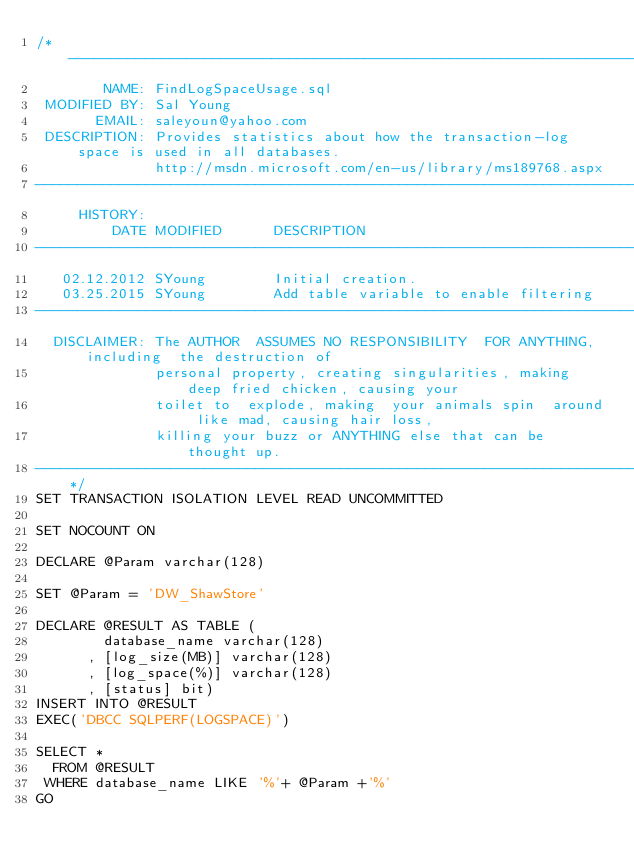Convert code to text. <code><loc_0><loc_0><loc_500><loc_500><_SQL_>/*-------------------------------------------------------------------------------------------------
        NAME: FindLogSpaceUsage.sql
 MODIFIED BY: Sal Young
       EMAIL: saleyoun@yahoo.com
 DESCRIPTION: Provides statistics about how the transaction-log space is used in all databases.
              http://msdn.microsoft.com/en-us/library/ms189768.aspx
-------------------------------------------------------------------------------------------------
     HISTORY:
         DATE MODIFIED      DESCRIPTION   
-------------------------------------------------------------------------------------------------
   02.12.2012 SYoung        Initial creation.
   03.25.2015 SYoung        Add table variable to enable filtering
-------------------------------------------------------------------------------------------------
  DISCLAIMER: The AUTHOR  ASSUMES NO RESPONSIBILITY  FOR ANYTHING, including  the destruction of 
              personal property, creating singularities, making deep fried chicken, causing your 
              toilet to  explode, making  your animals spin  around like mad, causing hair loss, 
              killing your buzz or ANYTHING else that can be thought up.
-------------------------------------------------------------------------------------------------*/
SET TRANSACTION ISOLATION LEVEL READ UNCOMMITTED

SET NOCOUNT ON

DECLARE @Param varchar(128)

SET @Param = 'DW_ShawStore'

DECLARE @RESULT AS TABLE (
        database_name varchar(128)
      , [log_size(MB)] varchar(128)
      , [log_space(%)] varchar(128)
      , [status] bit)
INSERT INTO @RESULT
EXEC('DBCC SQLPERF(LOGSPACE)')

SELECT * 
  FROM @RESULT
 WHERE database_name LIKE '%'+ @Param +'%'
GO
</code> 